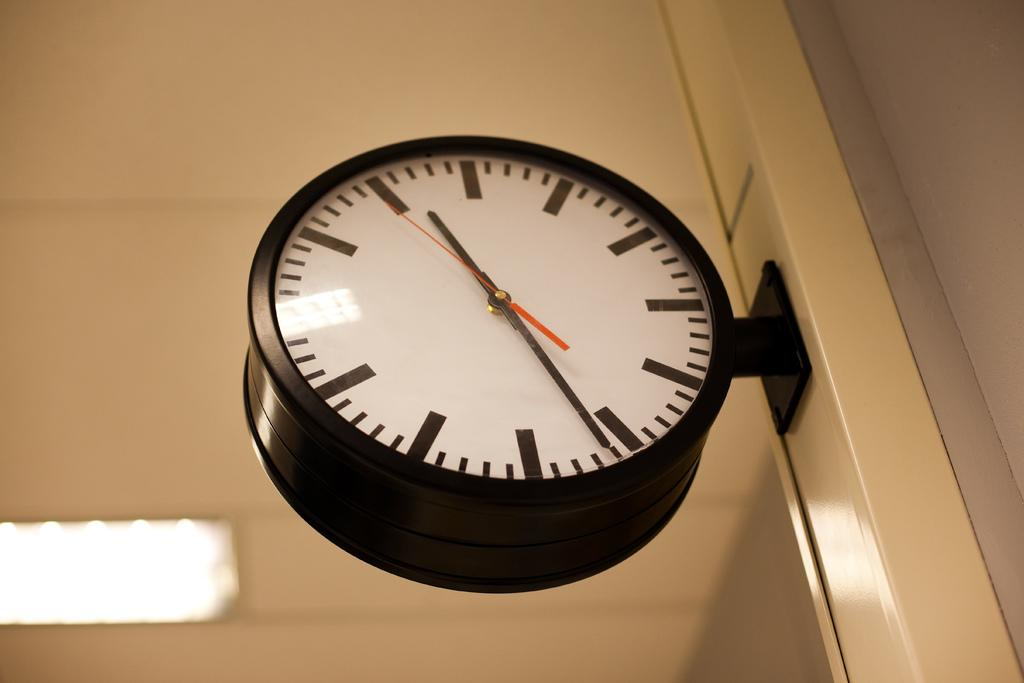What object in the image can be used to tell time? There is a clock in the image that can be used to tell time. What can be seen in the background of the image? There is a wall in the background of the image. What is attached to the wall in the image? There is a light on the wall in the image. What type of voice can be heard coming from the clock in the image? There is no voice coming from the clock in the image; it is a silent object used for telling time. 